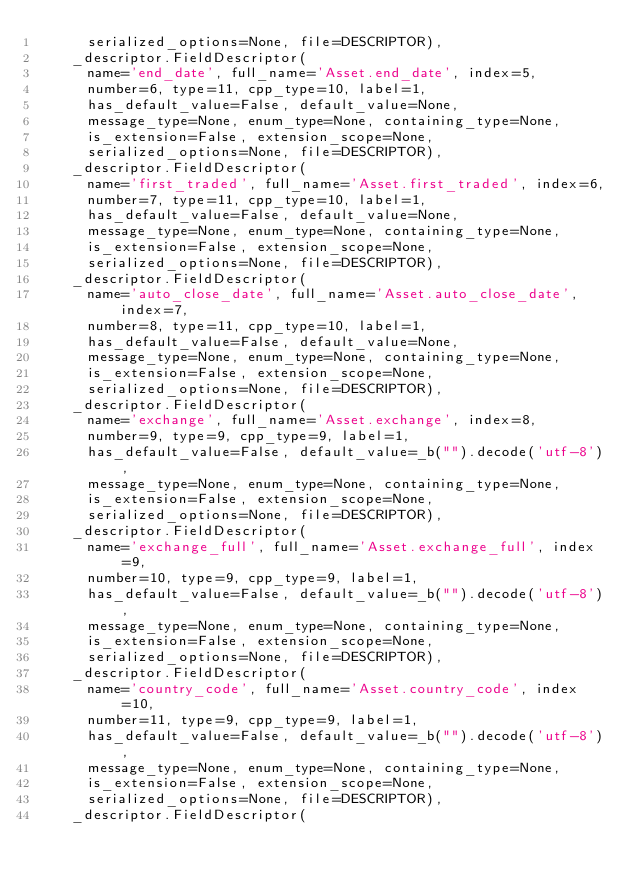Convert code to text. <code><loc_0><loc_0><loc_500><loc_500><_Python_>      serialized_options=None, file=DESCRIPTOR),
    _descriptor.FieldDescriptor(
      name='end_date', full_name='Asset.end_date', index=5,
      number=6, type=11, cpp_type=10, label=1,
      has_default_value=False, default_value=None,
      message_type=None, enum_type=None, containing_type=None,
      is_extension=False, extension_scope=None,
      serialized_options=None, file=DESCRIPTOR),
    _descriptor.FieldDescriptor(
      name='first_traded', full_name='Asset.first_traded', index=6,
      number=7, type=11, cpp_type=10, label=1,
      has_default_value=False, default_value=None,
      message_type=None, enum_type=None, containing_type=None,
      is_extension=False, extension_scope=None,
      serialized_options=None, file=DESCRIPTOR),
    _descriptor.FieldDescriptor(
      name='auto_close_date', full_name='Asset.auto_close_date', index=7,
      number=8, type=11, cpp_type=10, label=1,
      has_default_value=False, default_value=None,
      message_type=None, enum_type=None, containing_type=None,
      is_extension=False, extension_scope=None,
      serialized_options=None, file=DESCRIPTOR),
    _descriptor.FieldDescriptor(
      name='exchange', full_name='Asset.exchange', index=8,
      number=9, type=9, cpp_type=9, label=1,
      has_default_value=False, default_value=_b("").decode('utf-8'),
      message_type=None, enum_type=None, containing_type=None,
      is_extension=False, extension_scope=None,
      serialized_options=None, file=DESCRIPTOR),
    _descriptor.FieldDescriptor(
      name='exchange_full', full_name='Asset.exchange_full', index=9,
      number=10, type=9, cpp_type=9, label=1,
      has_default_value=False, default_value=_b("").decode('utf-8'),
      message_type=None, enum_type=None, containing_type=None,
      is_extension=False, extension_scope=None,
      serialized_options=None, file=DESCRIPTOR),
    _descriptor.FieldDescriptor(
      name='country_code', full_name='Asset.country_code', index=10,
      number=11, type=9, cpp_type=9, label=1,
      has_default_value=False, default_value=_b("").decode('utf-8'),
      message_type=None, enum_type=None, containing_type=None,
      is_extension=False, extension_scope=None,
      serialized_options=None, file=DESCRIPTOR),
    _descriptor.FieldDescriptor(</code> 